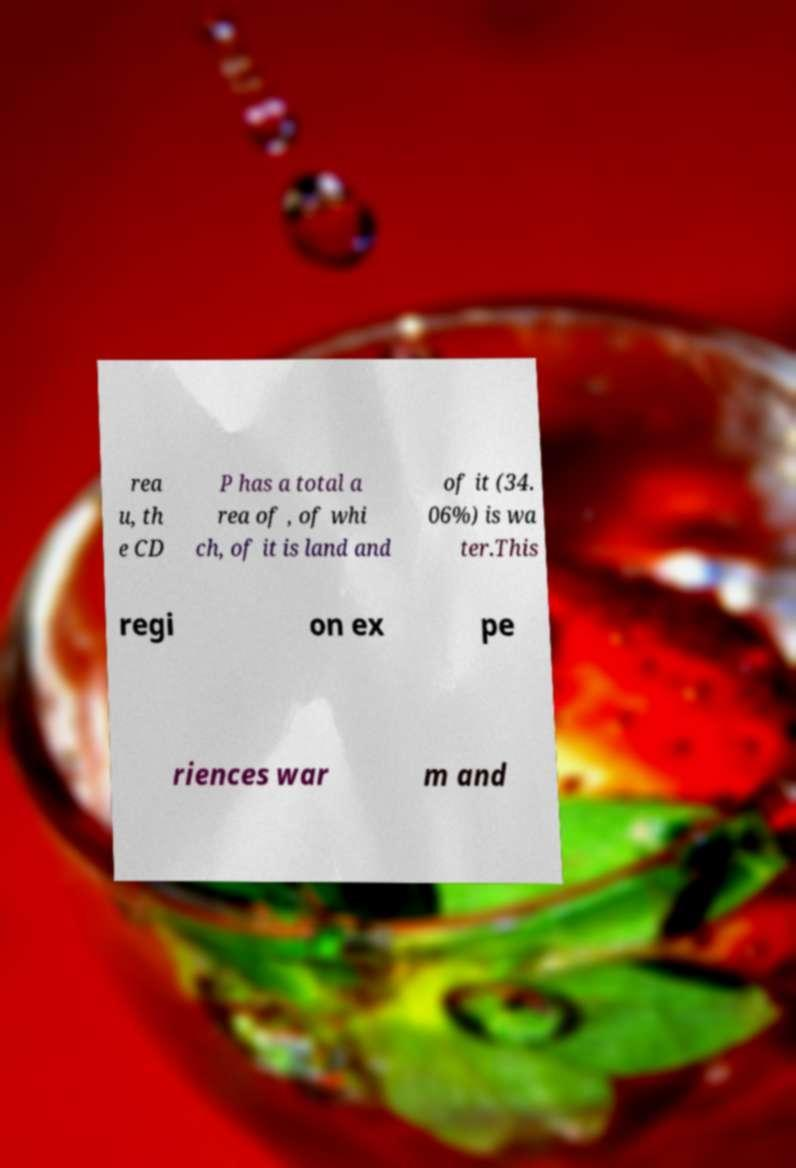What messages or text are displayed in this image? I need them in a readable, typed format. rea u, th e CD P has a total a rea of , of whi ch, of it is land and of it (34. 06%) is wa ter.This regi on ex pe riences war m and 